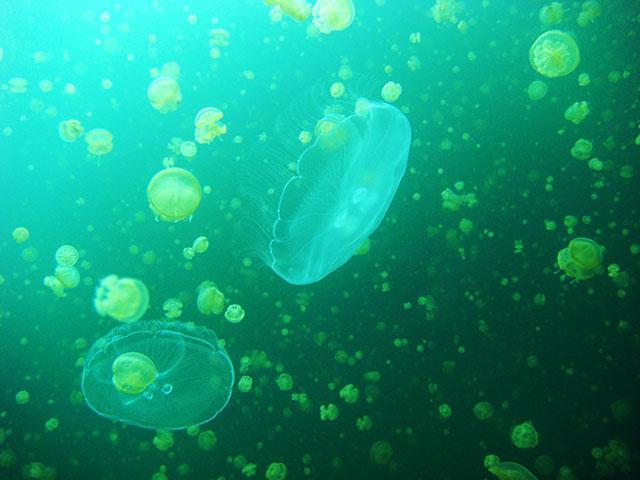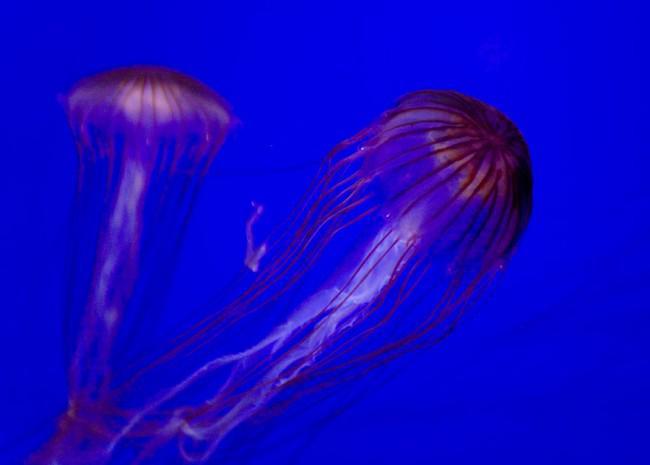The first image is the image on the left, the second image is the image on the right. Evaluate the accuracy of this statement regarding the images: "At least one image shows one orange jellyfish with frilly tendrils hanging down between stringlike ones.". Is it true? Answer yes or no. No. 